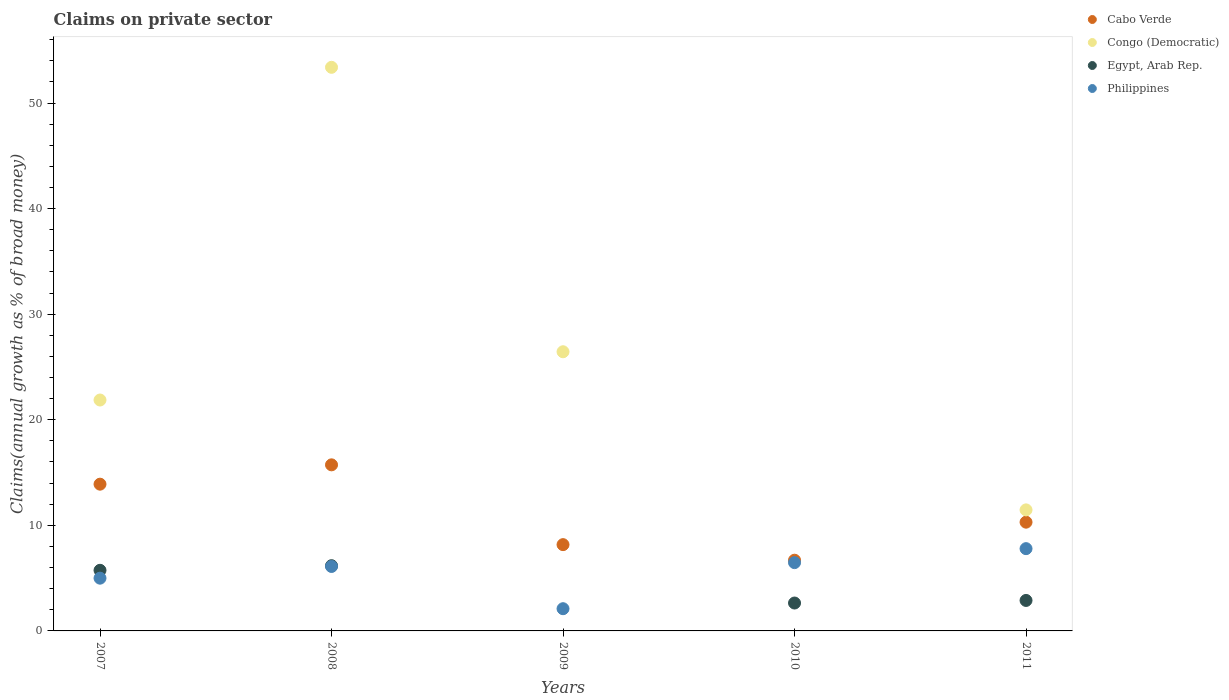Is the number of dotlines equal to the number of legend labels?
Your answer should be very brief. No. What is the percentage of broad money claimed on private sector in Cabo Verde in 2011?
Offer a very short reply. 10.3. Across all years, what is the maximum percentage of broad money claimed on private sector in Egypt, Arab Rep.?
Ensure brevity in your answer.  6.18. What is the total percentage of broad money claimed on private sector in Philippines in the graph?
Your response must be concise. 27.47. What is the difference between the percentage of broad money claimed on private sector in Cabo Verde in 2007 and that in 2009?
Offer a terse response. 5.73. What is the difference between the percentage of broad money claimed on private sector in Cabo Verde in 2007 and the percentage of broad money claimed on private sector in Egypt, Arab Rep. in 2010?
Your answer should be very brief. 11.26. What is the average percentage of broad money claimed on private sector in Philippines per year?
Your response must be concise. 5.49. In the year 2008, what is the difference between the percentage of broad money claimed on private sector in Cabo Verde and percentage of broad money claimed on private sector in Congo (Democratic)?
Make the answer very short. -37.65. What is the ratio of the percentage of broad money claimed on private sector in Cabo Verde in 2007 to that in 2010?
Give a very brief answer. 2.08. Is the difference between the percentage of broad money claimed on private sector in Cabo Verde in 2009 and 2011 greater than the difference between the percentage of broad money claimed on private sector in Congo (Democratic) in 2009 and 2011?
Your answer should be very brief. No. What is the difference between the highest and the second highest percentage of broad money claimed on private sector in Congo (Democratic)?
Your response must be concise. 26.94. What is the difference between the highest and the lowest percentage of broad money claimed on private sector in Philippines?
Your response must be concise. 5.69. In how many years, is the percentage of broad money claimed on private sector in Egypt, Arab Rep. greater than the average percentage of broad money claimed on private sector in Egypt, Arab Rep. taken over all years?
Your answer should be compact. 2. Is it the case that in every year, the sum of the percentage of broad money claimed on private sector in Cabo Verde and percentage of broad money claimed on private sector in Egypt, Arab Rep.  is greater than the sum of percentage of broad money claimed on private sector in Philippines and percentage of broad money claimed on private sector in Congo (Democratic)?
Keep it short and to the point. No. Is it the case that in every year, the sum of the percentage of broad money claimed on private sector in Cabo Verde and percentage of broad money claimed on private sector in Philippines  is greater than the percentage of broad money claimed on private sector in Egypt, Arab Rep.?
Your response must be concise. Yes. Does the percentage of broad money claimed on private sector in Congo (Democratic) monotonically increase over the years?
Your answer should be compact. No. What is the difference between two consecutive major ticks on the Y-axis?
Offer a very short reply. 10. Does the graph contain any zero values?
Your answer should be very brief. Yes. Does the graph contain grids?
Give a very brief answer. No. Where does the legend appear in the graph?
Ensure brevity in your answer.  Top right. How are the legend labels stacked?
Your answer should be very brief. Vertical. What is the title of the graph?
Your answer should be compact. Claims on private sector. Does "Benin" appear as one of the legend labels in the graph?
Your response must be concise. No. What is the label or title of the X-axis?
Ensure brevity in your answer.  Years. What is the label or title of the Y-axis?
Ensure brevity in your answer.  Claims(annual growth as % of broad money). What is the Claims(annual growth as % of broad money) in Cabo Verde in 2007?
Offer a terse response. 13.9. What is the Claims(annual growth as % of broad money) of Congo (Democratic) in 2007?
Your answer should be compact. 21.87. What is the Claims(annual growth as % of broad money) in Egypt, Arab Rep. in 2007?
Make the answer very short. 5.74. What is the Claims(annual growth as % of broad money) of Philippines in 2007?
Make the answer very short. 5. What is the Claims(annual growth as % of broad money) of Cabo Verde in 2008?
Make the answer very short. 15.73. What is the Claims(annual growth as % of broad money) of Congo (Democratic) in 2008?
Your answer should be compact. 53.38. What is the Claims(annual growth as % of broad money) in Egypt, Arab Rep. in 2008?
Provide a short and direct response. 6.18. What is the Claims(annual growth as % of broad money) of Philippines in 2008?
Give a very brief answer. 6.1. What is the Claims(annual growth as % of broad money) in Cabo Verde in 2009?
Offer a terse response. 8.17. What is the Claims(annual growth as % of broad money) in Congo (Democratic) in 2009?
Your answer should be very brief. 26.44. What is the Claims(annual growth as % of broad money) of Egypt, Arab Rep. in 2009?
Offer a terse response. 0. What is the Claims(annual growth as % of broad money) in Philippines in 2009?
Offer a very short reply. 2.1. What is the Claims(annual growth as % of broad money) of Cabo Verde in 2010?
Offer a terse response. 6.7. What is the Claims(annual growth as % of broad money) in Congo (Democratic) in 2010?
Your answer should be compact. 0. What is the Claims(annual growth as % of broad money) of Egypt, Arab Rep. in 2010?
Provide a short and direct response. 2.64. What is the Claims(annual growth as % of broad money) in Philippines in 2010?
Give a very brief answer. 6.47. What is the Claims(annual growth as % of broad money) of Cabo Verde in 2011?
Keep it short and to the point. 10.3. What is the Claims(annual growth as % of broad money) in Congo (Democratic) in 2011?
Your response must be concise. 11.46. What is the Claims(annual growth as % of broad money) of Egypt, Arab Rep. in 2011?
Your answer should be very brief. 2.89. What is the Claims(annual growth as % of broad money) of Philippines in 2011?
Provide a short and direct response. 7.79. Across all years, what is the maximum Claims(annual growth as % of broad money) of Cabo Verde?
Offer a very short reply. 15.73. Across all years, what is the maximum Claims(annual growth as % of broad money) in Congo (Democratic)?
Your response must be concise. 53.38. Across all years, what is the maximum Claims(annual growth as % of broad money) of Egypt, Arab Rep.?
Provide a short and direct response. 6.18. Across all years, what is the maximum Claims(annual growth as % of broad money) of Philippines?
Provide a succinct answer. 7.79. Across all years, what is the minimum Claims(annual growth as % of broad money) of Cabo Verde?
Offer a terse response. 6.7. Across all years, what is the minimum Claims(annual growth as % of broad money) in Egypt, Arab Rep.?
Your answer should be compact. 0. Across all years, what is the minimum Claims(annual growth as % of broad money) of Philippines?
Your answer should be very brief. 2.1. What is the total Claims(annual growth as % of broad money) of Cabo Verde in the graph?
Offer a very short reply. 54.8. What is the total Claims(annual growth as % of broad money) in Congo (Democratic) in the graph?
Your answer should be compact. 113.16. What is the total Claims(annual growth as % of broad money) in Egypt, Arab Rep. in the graph?
Provide a short and direct response. 17.45. What is the total Claims(annual growth as % of broad money) of Philippines in the graph?
Keep it short and to the point. 27.47. What is the difference between the Claims(annual growth as % of broad money) in Cabo Verde in 2007 and that in 2008?
Make the answer very short. -1.83. What is the difference between the Claims(annual growth as % of broad money) in Congo (Democratic) in 2007 and that in 2008?
Make the answer very short. -31.51. What is the difference between the Claims(annual growth as % of broad money) in Egypt, Arab Rep. in 2007 and that in 2008?
Make the answer very short. -0.44. What is the difference between the Claims(annual growth as % of broad money) in Philippines in 2007 and that in 2008?
Offer a very short reply. -1.11. What is the difference between the Claims(annual growth as % of broad money) in Cabo Verde in 2007 and that in 2009?
Provide a succinct answer. 5.73. What is the difference between the Claims(annual growth as % of broad money) of Congo (Democratic) in 2007 and that in 2009?
Provide a succinct answer. -4.57. What is the difference between the Claims(annual growth as % of broad money) in Philippines in 2007 and that in 2009?
Your answer should be compact. 2.89. What is the difference between the Claims(annual growth as % of broad money) in Cabo Verde in 2007 and that in 2010?
Ensure brevity in your answer.  7.2. What is the difference between the Claims(annual growth as % of broad money) in Egypt, Arab Rep. in 2007 and that in 2010?
Provide a succinct answer. 3.1. What is the difference between the Claims(annual growth as % of broad money) of Philippines in 2007 and that in 2010?
Provide a succinct answer. -1.47. What is the difference between the Claims(annual growth as % of broad money) in Cabo Verde in 2007 and that in 2011?
Give a very brief answer. 3.6. What is the difference between the Claims(annual growth as % of broad money) in Congo (Democratic) in 2007 and that in 2011?
Provide a succinct answer. 10.41. What is the difference between the Claims(annual growth as % of broad money) in Egypt, Arab Rep. in 2007 and that in 2011?
Ensure brevity in your answer.  2.86. What is the difference between the Claims(annual growth as % of broad money) of Philippines in 2007 and that in 2011?
Your answer should be very brief. -2.8. What is the difference between the Claims(annual growth as % of broad money) in Cabo Verde in 2008 and that in 2009?
Your answer should be very brief. 7.56. What is the difference between the Claims(annual growth as % of broad money) of Congo (Democratic) in 2008 and that in 2009?
Make the answer very short. 26.94. What is the difference between the Claims(annual growth as % of broad money) in Philippines in 2008 and that in 2009?
Make the answer very short. 4. What is the difference between the Claims(annual growth as % of broad money) in Cabo Verde in 2008 and that in 2010?
Ensure brevity in your answer.  9.03. What is the difference between the Claims(annual growth as % of broad money) in Egypt, Arab Rep. in 2008 and that in 2010?
Your answer should be very brief. 3.54. What is the difference between the Claims(annual growth as % of broad money) in Philippines in 2008 and that in 2010?
Provide a short and direct response. -0.36. What is the difference between the Claims(annual growth as % of broad money) in Cabo Verde in 2008 and that in 2011?
Your answer should be compact. 5.43. What is the difference between the Claims(annual growth as % of broad money) in Congo (Democratic) in 2008 and that in 2011?
Ensure brevity in your answer.  41.92. What is the difference between the Claims(annual growth as % of broad money) of Egypt, Arab Rep. in 2008 and that in 2011?
Offer a terse response. 3.29. What is the difference between the Claims(annual growth as % of broad money) of Philippines in 2008 and that in 2011?
Offer a very short reply. -1.69. What is the difference between the Claims(annual growth as % of broad money) of Cabo Verde in 2009 and that in 2010?
Your answer should be very brief. 1.47. What is the difference between the Claims(annual growth as % of broad money) in Philippines in 2009 and that in 2010?
Make the answer very short. -4.36. What is the difference between the Claims(annual growth as % of broad money) in Cabo Verde in 2009 and that in 2011?
Offer a terse response. -2.13. What is the difference between the Claims(annual growth as % of broad money) of Congo (Democratic) in 2009 and that in 2011?
Ensure brevity in your answer.  14.98. What is the difference between the Claims(annual growth as % of broad money) of Philippines in 2009 and that in 2011?
Give a very brief answer. -5.69. What is the difference between the Claims(annual growth as % of broad money) in Cabo Verde in 2010 and that in 2011?
Keep it short and to the point. -3.6. What is the difference between the Claims(annual growth as % of broad money) of Egypt, Arab Rep. in 2010 and that in 2011?
Your answer should be very brief. -0.24. What is the difference between the Claims(annual growth as % of broad money) in Philippines in 2010 and that in 2011?
Your answer should be very brief. -1.32. What is the difference between the Claims(annual growth as % of broad money) in Cabo Verde in 2007 and the Claims(annual growth as % of broad money) in Congo (Democratic) in 2008?
Make the answer very short. -39.48. What is the difference between the Claims(annual growth as % of broad money) in Cabo Verde in 2007 and the Claims(annual growth as % of broad money) in Egypt, Arab Rep. in 2008?
Offer a terse response. 7.72. What is the difference between the Claims(annual growth as % of broad money) of Cabo Verde in 2007 and the Claims(annual growth as % of broad money) of Philippines in 2008?
Your answer should be very brief. 7.8. What is the difference between the Claims(annual growth as % of broad money) in Congo (Democratic) in 2007 and the Claims(annual growth as % of broad money) in Egypt, Arab Rep. in 2008?
Your answer should be very brief. 15.69. What is the difference between the Claims(annual growth as % of broad money) of Congo (Democratic) in 2007 and the Claims(annual growth as % of broad money) of Philippines in 2008?
Your answer should be compact. 15.77. What is the difference between the Claims(annual growth as % of broad money) of Egypt, Arab Rep. in 2007 and the Claims(annual growth as % of broad money) of Philippines in 2008?
Provide a short and direct response. -0.36. What is the difference between the Claims(annual growth as % of broad money) in Cabo Verde in 2007 and the Claims(annual growth as % of broad money) in Congo (Democratic) in 2009?
Provide a short and direct response. -12.54. What is the difference between the Claims(annual growth as % of broad money) of Cabo Verde in 2007 and the Claims(annual growth as % of broad money) of Philippines in 2009?
Make the answer very short. 11.8. What is the difference between the Claims(annual growth as % of broad money) in Congo (Democratic) in 2007 and the Claims(annual growth as % of broad money) in Philippines in 2009?
Keep it short and to the point. 19.77. What is the difference between the Claims(annual growth as % of broad money) in Egypt, Arab Rep. in 2007 and the Claims(annual growth as % of broad money) in Philippines in 2009?
Give a very brief answer. 3.64. What is the difference between the Claims(annual growth as % of broad money) in Cabo Verde in 2007 and the Claims(annual growth as % of broad money) in Egypt, Arab Rep. in 2010?
Keep it short and to the point. 11.26. What is the difference between the Claims(annual growth as % of broad money) of Cabo Verde in 2007 and the Claims(annual growth as % of broad money) of Philippines in 2010?
Make the answer very short. 7.43. What is the difference between the Claims(annual growth as % of broad money) in Congo (Democratic) in 2007 and the Claims(annual growth as % of broad money) in Egypt, Arab Rep. in 2010?
Make the answer very short. 19.23. What is the difference between the Claims(annual growth as % of broad money) of Congo (Democratic) in 2007 and the Claims(annual growth as % of broad money) of Philippines in 2010?
Your answer should be compact. 15.4. What is the difference between the Claims(annual growth as % of broad money) in Egypt, Arab Rep. in 2007 and the Claims(annual growth as % of broad money) in Philippines in 2010?
Your answer should be very brief. -0.73. What is the difference between the Claims(annual growth as % of broad money) of Cabo Verde in 2007 and the Claims(annual growth as % of broad money) of Congo (Democratic) in 2011?
Your answer should be compact. 2.44. What is the difference between the Claims(annual growth as % of broad money) of Cabo Verde in 2007 and the Claims(annual growth as % of broad money) of Egypt, Arab Rep. in 2011?
Provide a short and direct response. 11.01. What is the difference between the Claims(annual growth as % of broad money) of Cabo Verde in 2007 and the Claims(annual growth as % of broad money) of Philippines in 2011?
Provide a succinct answer. 6.11. What is the difference between the Claims(annual growth as % of broad money) in Congo (Democratic) in 2007 and the Claims(annual growth as % of broad money) in Egypt, Arab Rep. in 2011?
Make the answer very short. 18.98. What is the difference between the Claims(annual growth as % of broad money) in Congo (Democratic) in 2007 and the Claims(annual growth as % of broad money) in Philippines in 2011?
Offer a terse response. 14.08. What is the difference between the Claims(annual growth as % of broad money) in Egypt, Arab Rep. in 2007 and the Claims(annual growth as % of broad money) in Philippines in 2011?
Offer a terse response. -2.05. What is the difference between the Claims(annual growth as % of broad money) of Cabo Verde in 2008 and the Claims(annual growth as % of broad money) of Congo (Democratic) in 2009?
Offer a very short reply. -10.71. What is the difference between the Claims(annual growth as % of broad money) in Cabo Verde in 2008 and the Claims(annual growth as % of broad money) in Philippines in 2009?
Give a very brief answer. 13.63. What is the difference between the Claims(annual growth as % of broad money) in Congo (Democratic) in 2008 and the Claims(annual growth as % of broad money) in Philippines in 2009?
Provide a succinct answer. 51.28. What is the difference between the Claims(annual growth as % of broad money) of Egypt, Arab Rep. in 2008 and the Claims(annual growth as % of broad money) of Philippines in 2009?
Offer a terse response. 4.07. What is the difference between the Claims(annual growth as % of broad money) in Cabo Verde in 2008 and the Claims(annual growth as % of broad money) in Egypt, Arab Rep. in 2010?
Your answer should be compact. 13.09. What is the difference between the Claims(annual growth as % of broad money) of Cabo Verde in 2008 and the Claims(annual growth as % of broad money) of Philippines in 2010?
Your response must be concise. 9.26. What is the difference between the Claims(annual growth as % of broad money) of Congo (Democratic) in 2008 and the Claims(annual growth as % of broad money) of Egypt, Arab Rep. in 2010?
Give a very brief answer. 50.74. What is the difference between the Claims(annual growth as % of broad money) of Congo (Democratic) in 2008 and the Claims(annual growth as % of broad money) of Philippines in 2010?
Keep it short and to the point. 46.92. What is the difference between the Claims(annual growth as % of broad money) in Egypt, Arab Rep. in 2008 and the Claims(annual growth as % of broad money) in Philippines in 2010?
Your answer should be very brief. -0.29. What is the difference between the Claims(annual growth as % of broad money) in Cabo Verde in 2008 and the Claims(annual growth as % of broad money) in Congo (Democratic) in 2011?
Ensure brevity in your answer.  4.27. What is the difference between the Claims(annual growth as % of broad money) in Cabo Verde in 2008 and the Claims(annual growth as % of broad money) in Egypt, Arab Rep. in 2011?
Make the answer very short. 12.84. What is the difference between the Claims(annual growth as % of broad money) of Cabo Verde in 2008 and the Claims(annual growth as % of broad money) of Philippines in 2011?
Provide a succinct answer. 7.94. What is the difference between the Claims(annual growth as % of broad money) in Congo (Democratic) in 2008 and the Claims(annual growth as % of broad money) in Egypt, Arab Rep. in 2011?
Give a very brief answer. 50.5. What is the difference between the Claims(annual growth as % of broad money) in Congo (Democratic) in 2008 and the Claims(annual growth as % of broad money) in Philippines in 2011?
Give a very brief answer. 45.59. What is the difference between the Claims(annual growth as % of broad money) in Egypt, Arab Rep. in 2008 and the Claims(annual growth as % of broad money) in Philippines in 2011?
Your answer should be compact. -1.61. What is the difference between the Claims(annual growth as % of broad money) of Cabo Verde in 2009 and the Claims(annual growth as % of broad money) of Egypt, Arab Rep. in 2010?
Your response must be concise. 5.53. What is the difference between the Claims(annual growth as % of broad money) of Cabo Verde in 2009 and the Claims(annual growth as % of broad money) of Philippines in 2010?
Make the answer very short. 1.7. What is the difference between the Claims(annual growth as % of broad money) in Congo (Democratic) in 2009 and the Claims(annual growth as % of broad money) in Egypt, Arab Rep. in 2010?
Make the answer very short. 23.8. What is the difference between the Claims(annual growth as % of broad money) of Congo (Democratic) in 2009 and the Claims(annual growth as % of broad money) of Philippines in 2010?
Your answer should be compact. 19.97. What is the difference between the Claims(annual growth as % of broad money) in Cabo Verde in 2009 and the Claims(annual growth as % of broad money) in Congo (Democratic) in 2011?
Provide a short and direct response. -3.29. What is the difference between the Claims(annual growth as % of broad money) of Cabo Verde in 2009 and the Claims(annual growth as % of broad money) of Egypt, Arab Rep. in 2011?
Your response must be concise. 5.29. What is the difference between the Claims(annual growth as % of broad money) of Cabo Verde in 2009 and the Claims(annual growth as % of broad money) of Philippines in 2011?
Provide a short and direct response. 0.38. What is the difference between the Claims(annual growth as % of broad money) in Congo (Democratic) in 2009 and the Claims(annual growth as % of broad money) in Egypt, Arab Rep. in 2011?
Give a very brief answer. 23.56. What is the difference between the Claims(annual growth as % of broad money) of Congo (Democratic) in 2009 and the Claims(annual growth as % of broad money) of Philippines in 2011?
Give a very brief answer. 18.65. What is the difference between the Claims(annual growth as % of broad money) of Cabo Verde in 2010 and the Claims(annual growth as % of broad money) of Congo (Democratic) in 2011?
Ensure brevity in your answer.  -4.77. What is the difference between the Claims(annual growth as % of broad money) in Cabo Verde in 2010 and the Claims(annual growth as % of broad money) in Egypt, Arab Rep. in 2011?
Your response must be concise. 3.81. What is the difference between the Claims(annual growth as % of broad money) of Cabo Verde in 2010 and the Claims(annual growth as % of broad money) of Philippines in 2011?
Your answer should be compact. -1.09. What is the difference between the Claims(annual growth as % of broad money) in Egypt, Arab Rep. in 2010 and the Claims(annual growth as % of broad money) in Philippines in 2011?
Offer a terse response. -5.15. What is the average Claims(annual growth as % of broad money) of Cabo Verde per year?
Provide a short and direct response. 10.96. What is the average Claims(annual growth as % of broad money) in Congo (Democratic) per year?
Your response must be concise. 22.63. What is the average Claims(annual growth as % of broad money) of Egypt, Arab Rep. per year?
Ensure brevity in your answer.  3.49. What is the average Claims(annual growth as % of broad money) of Philippines per year?
Provide a succinct answer. 5.49. In the year 2007, what is the difference between the Claims(annual growth as % of broad money) in Cabo Verde and Claims(annual growth as % of broad money) in Congo (Democratic)?
Your answer should be very brief. -7.97. In the year 2007, what is the difference between the Claims(annual growth as % of broad money) of Cabo Verde and Claims(annual growth as % of broad money) of Egypt, Arab Rep.?
Give a very brief answer. 8.16. In the year 2007, what is the difference between the Claims(annual growth as % of broad money) of Cabo Verde and Claims(annual growth as % of broad money) of Philippines?
Provide a succinct answer. 8.9. In the year 2007, what is the difference between the Claims(annual growth as % of broad money) in Congo (Democratic) and Claims(annual growth as % of broad money) in Egypt, Arab Rep.?
Your answer should be very brief. 16.13. In the year 2007, what is the difference between the Claims(annual growth as % of broad money) of Congo (Democratic) and Claims(annual growth as % of broad money) of Philippines?
Make the answer very short. 16.87. In the year 2007, what is the difference between the Claims(annual growth as % of broad money) of Egypt, Arab Rep. and Claims(annual growth as % of broad money) of Philippines?
Offer a terse response. 0.75. In the year 2008, what is the difference between the Claims(annual growth as % of broad money) of Cabo Verde and Claims(annual growth as % of broad money) of Congo (Democratic)?
Your answer should be very brief. -37.65. In the year 2008, what is the difference between the Claims(annual growth as % of broad money) of Cabo Verde and Claims(annual growth as % of broad money) of Egypt, Arab Rep.?
Your answer should be very brief. 9.55. In the year 2008, what is the difference between the Claims(annual growth as % of broad money) of Cabo Verde and Claims(annual growth as % of broad money) of Philippines?
Keep it short and to the point. 9.63. In the year 2008, what is the difference between the Claims(annual growth as % of broad money) in Congo (Democratic) and Claims(annual growth as % of broad money) in Egypt, Arab Rep.?
Offer a terse response. 47.21. In the year 2008, what is the difference between the Claims(annual growth as % of broad money) of Congo (Democratic) and Claims(annual growth as % of broad money) of Philippines?
Your answer should be compact. 47.28. In the year 2008, what is the difference between the Claims(annual growth as % of broad money) in Egypt, Arab Rep. and Claims(annual growth as % of broad money) in Philippines?
Offer a terse response. 0.07. In the year 2009, what is the difference between the Claims(annual growth as % of broad money) in Cabo Verde and Claims(annual growth as % of broad money) in Congo (Democratic)?
Ensure brevity in your answer.  -18.27. In the year 2009, what is the difference between the Claims(annual growth as % of broad money) in Cabo Verde and Claims(annual growth as % of broad money) in Philippines?
Make the answer very short. 6.07. In the year 2009, what is the difference between the Claims(annual growth as % of broad money) of Congo (Democratic) and Claims(annual growth as % of broad money) of Philippines?
Your answer should be compact. 24.34. In the year 2010, what is the difference between the Claims(annual growth as % of broad money) in Cabo Verde and Claims(annual growth as % of broad money) in Egypt, Arab Rep.?
Make the answer very short. 4.06. In the year 2010, what is the difference between the Claims(annual growth as % of broad money) of Cabo Verde and Claims(annual growth as % of broad money) of Philippines?
Keep it short and to the point. 0.23. In the year 2010, what is the difference between the Claims(annual growth as % of broad money) in Egypt, Arab Rep. and Claims(annual growth as % of broad money) in Philippines?
Your answer should be compact. -3.83. In the year 2011, what is the difference between the Claims(annual growth as % of broad money) of Cabo Verde and Claims(annual growth as % of broad money) of Congo (Democratic)?
Your response must be concise. -1.16. In the year 2011, what is the difference between the Claims(annual growth as % of broad money) in Cabo Verde and Claims(annual growth as % of broad money) in Egypt, Arab Rep.?
Provide a short and direct response. 7.41. In the year 2011, what is the difference between the Claims(annual growth as % of broad money) of Cabo Verde and Claims(annual growth as % of broad money) of Philippines?
Your answer should be compact. 2.51. In the year 2011, what is the difference between the Claims(annual growth as % of broad money) of Congo (Democratic) and Claims(annual growth as % of broad money) of Egypt, Arab Rep.?
Make the answer very short. 8.58. In the year 2011, what is the difference between the Claims(annual growth as % of broad money) of Congo (Democratic) and Claims(annual growth as % of broad money) of Philippines?
Your response must be concise. 3.67. In the year 2011, what is the difference between the Claims(annual growth as % of broad money) in Egypt, Arab Rep. and Claims(annual growth as % of broad money) in Philippines?
Your response must be concise. -4.91. What is the ratio of the Claims(annual growth as % of broad money) in Cabo Verde in 2007 to that in 2008?
Give a very brief answer. 0.88. What is the ratio of the Claims(annual growth as % of broad money) in Congo (Democratic) in 2007 to that in 2008?
Provide a short and direct response. 0.41. What is the ratio of the Claims(annual growth as % of broad money) of Egypt, Arab Rep. in 2007 to that in 2008?
Your response must be concise. 0.93. What is the ratio of the Claims(annual growth as % of broad money) of Philippines in 2007 to that in 2008?
Make the answer very short. 0.82. What is the ratio of the Claims(annual growth as % of broad money) of Cabo Verde in 2007 to that in 2009?
Your answer should be very brief. 1.7. What is the ratio of the Claims(annual growth as % of broad money) in Congo (Democratic) in 2007 to that in 2009?
Provide a succinct answer. 0.83. What is the ratio of the Claims(annual growth as % of broad money) in Philippines in 2007 to that in 2009?
Keep it short and to the point. 2.37. What is the ratio of the Claims(annual growth as % of broad money) of Cabo Verde in 2007 to that in 2010?
Ensure brevity in your answer.  2.08. What is the ratio of the Claims(annual growth as % of broad money) of Egypt, Arab Rep. in 2007 to that in 2010?
Keep it short and to the point. 2.17. What is the ratio of the Claims(annual growth as % of broad money) of Philippines in 2007 to that in 2010?
Your answer should be very brief. 0.77. What is the ratio of the Claims(annual growth as % of broad money) in Cabo Verde in 2007 to that in 2011?
Offer a terse response. 1.35. What is the ratio of the Claims(annual growth as % of broad money) of Congo (Democratic) in 2007 to that in 2011?
Give a very brief answer. 1.91. What is the ratio of the Claims(annual growth as % of broad money) of Egypt, Arab Rep. in 2007 to that in 2011?
Offer a terse response. 1.99. What is the ratio of the Claims(annual growth as % of broad money) in Philippines in 2007 to that in 2011?
Your response must be concise. 0.64. What is the ratio of the Claims(annual growth as % of broad money) of Cabo Verde in 2008 to that in 2009?
Provide a succinct answer. 1.92. What is the ratio of the Claims(annual growth as % of broad money) of Congo (Democratic) in 2008 to that in 2009?
Your answer should be very brief. 2.02. What is the ratio of the Claims(annual growth as % of broad money) of Philippines in 2008 to that in 2009?
Provide a succinct answer. 2.9. What is the ratio of the Claims(annual growth as % of broad money) in Cabo Verde in 2008 to that in 2010?
Give a very brief answer. 2.35. What is the ratio of the Claims(annual growth as % of broad money) in Egypt, Arab Rep. in 2008 to that in 2010?
Keep it short and to the point. 2.34. What is the ratio of the Claims(annual growth as % of broad money) in Philippines in 2008 to that in 2010?
Keep it short and to the point. 0.94. What is the ratio of the Claims(annual growth as % of broad money) of Cabo Verde in 2008 to that in 2011?
Ensure brevity in your answer.  1.53. What is the ratio of the Claims(annual growth as % of broad money) in Congo (Democratic) in 2008 to that in 2011?
Give a very brief answer. 4.66. What is the ratio of the Claims(annual growth as % of broad money) in Egypt, Arab Rep. in 2008 to that in 2011?
Your answer should be compact. 2.14. What is the ratio of the Claims(annual growth as % of broad money) in Philippines in 2008 to that in 2011?
Your answer should be compact. 0.78. What is the ratio of the Claims(annual growth as % of broad money) of Cabo Verde in 2009 to that in 2010?
Provide a succinct answer. 1.22. What is the ratio of the Claims(annual growth as % of broad money) in Philippines in 2009 to that in 2010?
Provide a short and direct response. 0.33. What is the ratio of the Claims(annual growth as % of broad money) of Cabo Verde in 2009 to that in 2011?
Offer a terse response. 0.79. What is the ratio of the Claims(annual growth as % of broad money) of Congo (Democratic) in 2009 to that in 2011?
Offer a very short reply. 2.31. What is the ratio of the Claims(annual growth as % of broad money) of Philippines in 2009 to that in 2011?
Offer a very short reply. 0.27. What is the ratio of the Claims(annual growth as % of broad money) of Cabo Verde in 2010 to that in 2011?
Ensure brevity in your answer.  0.65. What is the ratio of the Claims(annual growth as % of broad money) in Egypt, Arab Rep. in 2010 to that in 2011?
Keep it short and to the point. 0.92. What is the ratio of the Claims(annual growth as % of broad money) in Philippines in 2010 to that in 2011?
Give a very brief answer. 0.83. What is the difference between the highest and the second highest Claims(annual growth as % of broad money) of Cabo Verde?
Offer a terse response. 1.83. What is the difference between the highest and the second highest Claims(annual growth as % of broad money) in Congo (Democratic)?
Your answer should be compact. 26.94. What is the difference between the highest and the second highest Claims(annual growth as % of broad money) in Egypt, Arab Rep.?
Offer a terse response. 0.44. What is the difference between the highest and the second highest Claims(annual growth as % of broad money) of Philippines?
Offer a very short reply. 1.32. What is the difference between the highest and the lowest Claims(annual growth as % of broad money) of Cabo Verde?
Give a very brief answer. 9.03. What is the difference between the highest and the lowest Claims(annual growth as % of broad money) of Congo (Democratic)?
Ensure brevity in your answer.  53.38. What is the difference between the highest and the lowest Claims(annual growth as % of broad money) in Egypt, Arab Rep.?
Provide a succinct answer. 6.18. What is the difference between the highest and the lowest Claims(annual growth as % of broad money) in Philippines?
Your answer should be very brief. 5.69. 